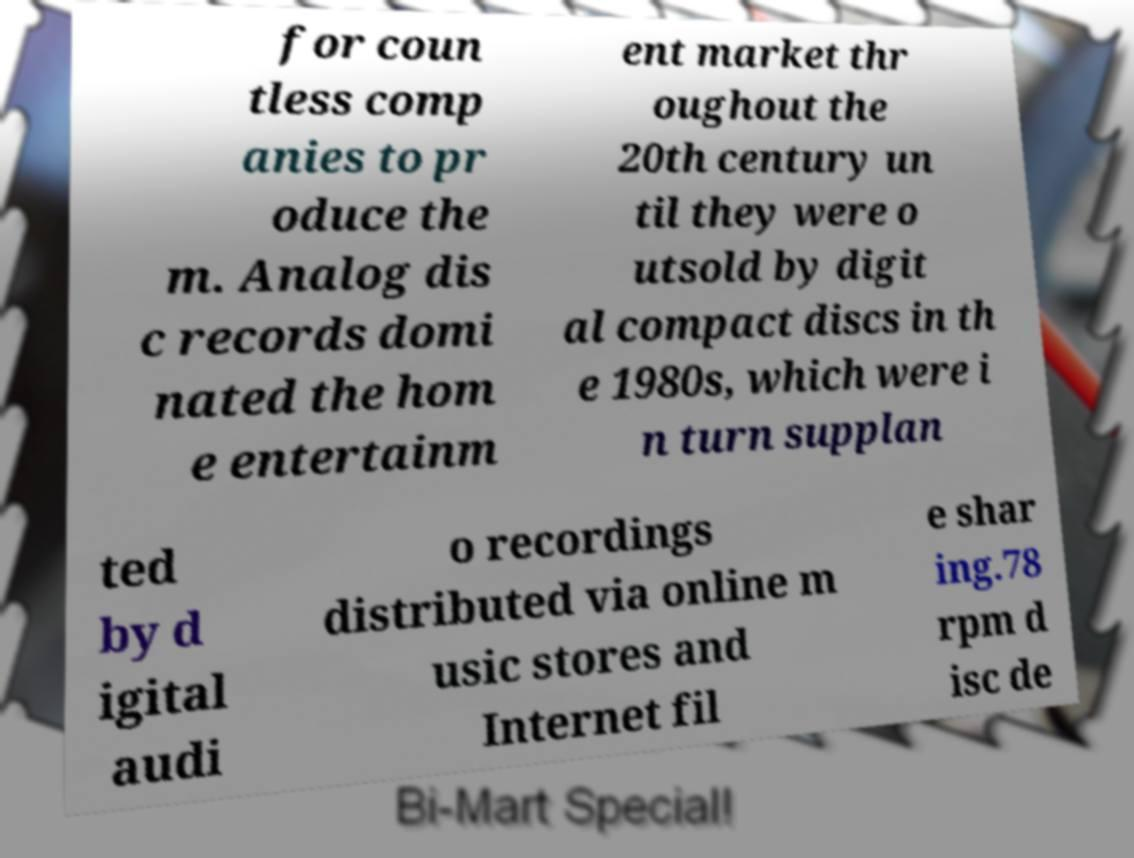Can you read and provide the text displayed in the image?This photo seems to have some interesting text. Can you extract and type it out for me? for coun tless comp anies to pr oduce the m. Analog dis c records domi nated the hom e entertainm ent market thr oughout the 20th century un til they were o utsold by digit al compact discs in th e 1980s, which were i n turn supplan ted by d igital audi o recordings distributed via online m usic stores and Internet fil e shar ing.78 rpm d isc de 